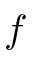Convert formula to latex. <formula><loc_0><loc_0><loc_500><loc_500>f</formula> 